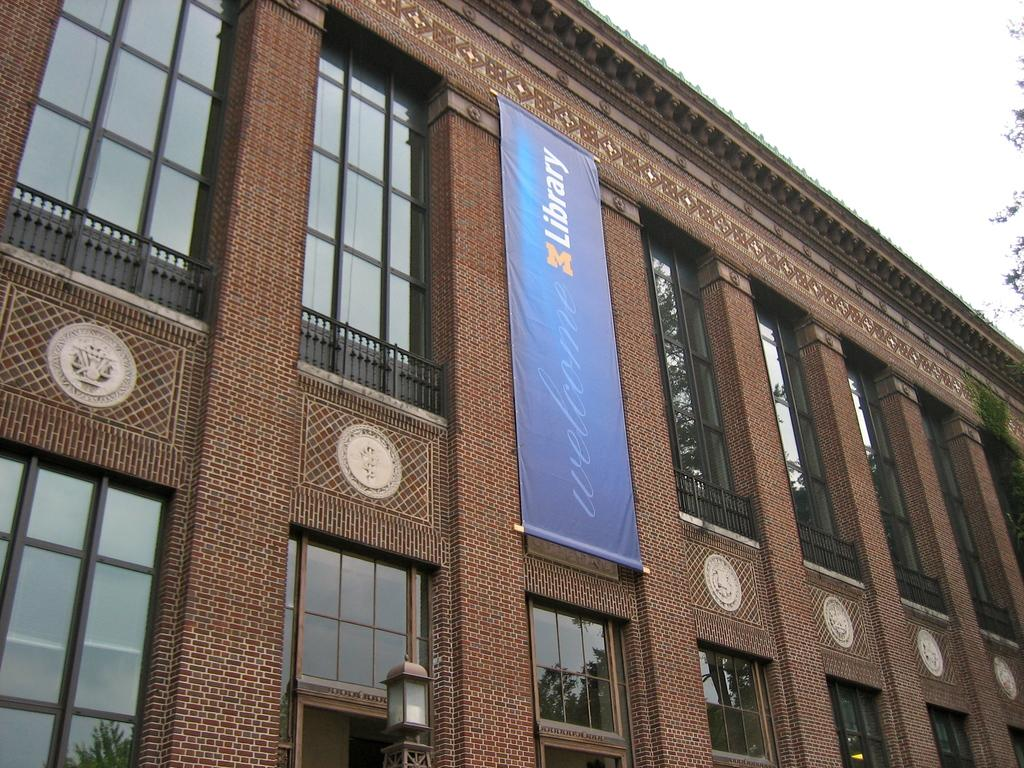<image>
Summarize the visual content of the image. A red brick building with a blue banner for the Michigan library. 